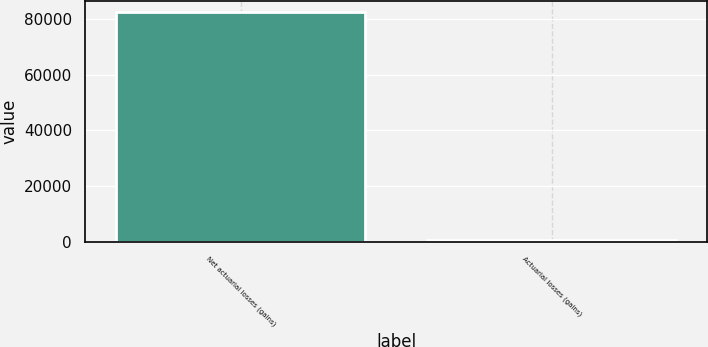Convert chart. <chart><loc_0><loc_0><loc_500><loc_500><bar_chart><fcel>Net actuarial losses (gains)<fcel>Actuarial losses (gains)<nl><fcel>82427<fcel>845<nl></chart> 